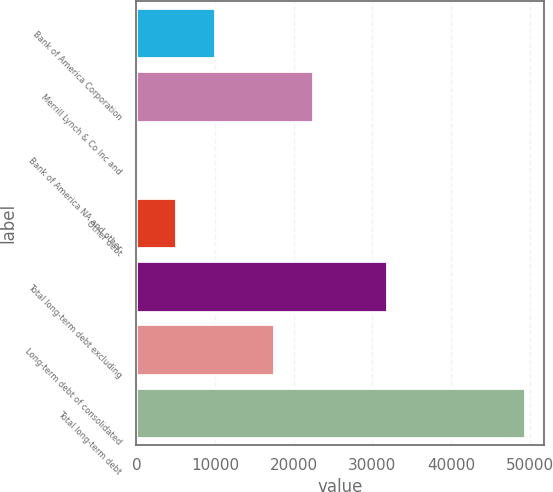Convert chart to OTSL. <chart><loc_0><loc_0><loc_500><loc_500><bar_chart><fcel>Bank of America Corporation<fcel>Merrill Lynch & Co Inc and<fcel>Bank of America NA and other<fcel>Other debt<fcel>Total long-term debt excluding<fcel>Long-term debt of consolidated<fcel>Total long-term debt<nl><fcel>9963.9<fcel>22446.9<fcel>86<fcel>5031<fcel>31901<fcel>17514<fcel>49415<nl></chart> 